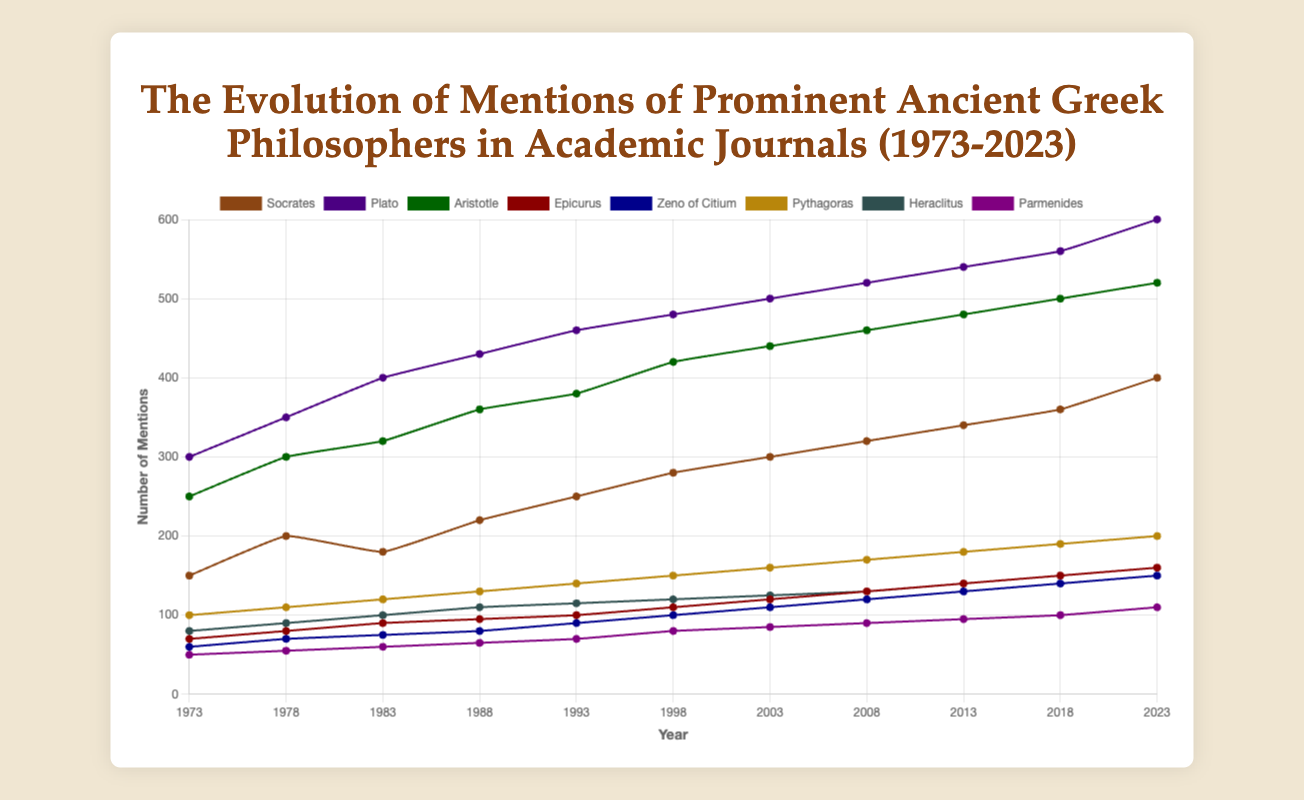What was the total number of mentions for Socrates between 1973 and 2023? Sum the mentions of Socrates in all data points: 150 + 200 + 180 + 220 + 250 + 280 + 300 + 320 + 340 + 360 + 400 = 3000
Answer: 3000 Which philosopher had the highest increase in mentions from 1973 to 2023? Compare the difference in mentions for each philosopher between 1973 and 2023: Socrates (400-150=250), Plato (600-300=300), Aristotle (520-250=270), Epicurus (160-70=90), Zeno of Citium (150-60=90), Pythagoras (200-100=100), Heraclitus (160-80=80), Parmenides (110-50=60). Plato had the highest increase.
Answer: Plato Looking at the chart, which philosopher consistently had the lowest number of mentions across the 50 years? Identify the philosopher whose counts are the lowest in each year: Zeno of Citium and Parmenides have lower mentions than others in each year, but overall Parmenides has the absolute lowest mentions.
Answer: Parmenides From 1993 to 1998, which philosopher experienced the highest rate of growth in mentions? Calculate the rate of growth for each philosopher between 1993 and 1998: e.g., Socrates ((280-250)/250=0.12), Plato ((480-460)/460=0.043), Aristotle ((420-380)/380=0.105), Epicurus ((110-100)/100=0.1), Zeno of Citium ((100-90)/90=0.111), Pythagoras ((150-140)/140=0.071), Heraclitus ((120-115)/115=0.043), Parmenides ((80-70)/70=0.143). Parmenides had the highest rate of growth.
Answer: Parmenides In which year did Epicurus and Zeno of Citium have the same number of mentions? Compare the counts of mentions for Epicurus and Zeno of Citium across the years: In 1993, both had 90 mentions.
Answer: 1993 Which philosopher had a consistently linear growth in mentions across the 50 years? Check each philosopher's mentions to see if they increase linearly: Pythagoras's mentions increased by exactly 10 mentions every 5 years, indicating linear growth.
Answer: Pythagoras In terms of the highest peak of mentions, which philosopher had the maximum value, and what was that value? Check the maximum value of counts for each philosopher to identify the highest value: Plato had the highest mentions in 2023 with 600 mentions.
Answer: Plato, 600 Compare mentions of Socrates and Aristotle in 2003. Which philosopher had more mentions, and by how much? Check mentions for Socrates (300) and Aristotle (440) in 2003: Aristotle had more mentions than Socrates by 140.
Answer: Aristotle, 140 How many philosophers reached 100 mentions before or in 2000? Check each philosopher's mentions to see if they reached 100 mentions by 2000: Socrates (yes), Plato (yes), Aristotle (yes), Epicurus (yes), Zeno of Citium (yes), Pythagoras (yes), Heraclitus (yes), Parmenides (no). 7 philosophers reached this milestone.
Answer: 7 